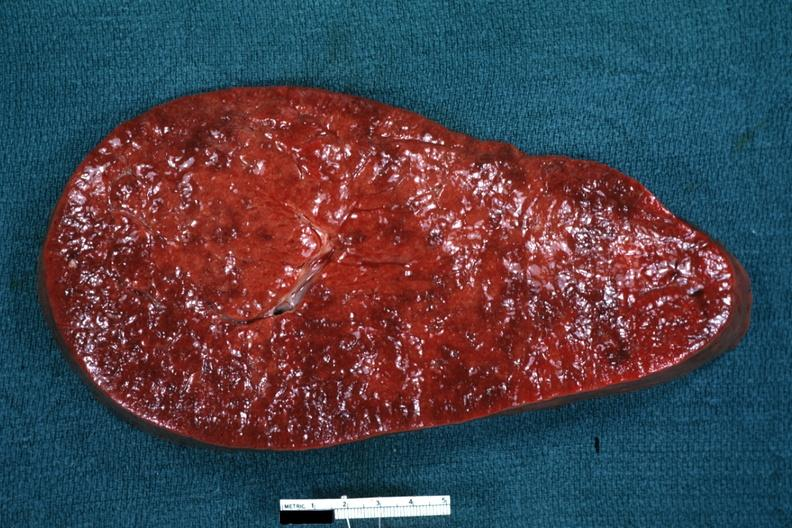what does this image show?
Answer the question using a single word or phrase. Enlarged spleen with rather obvious infiltrate 